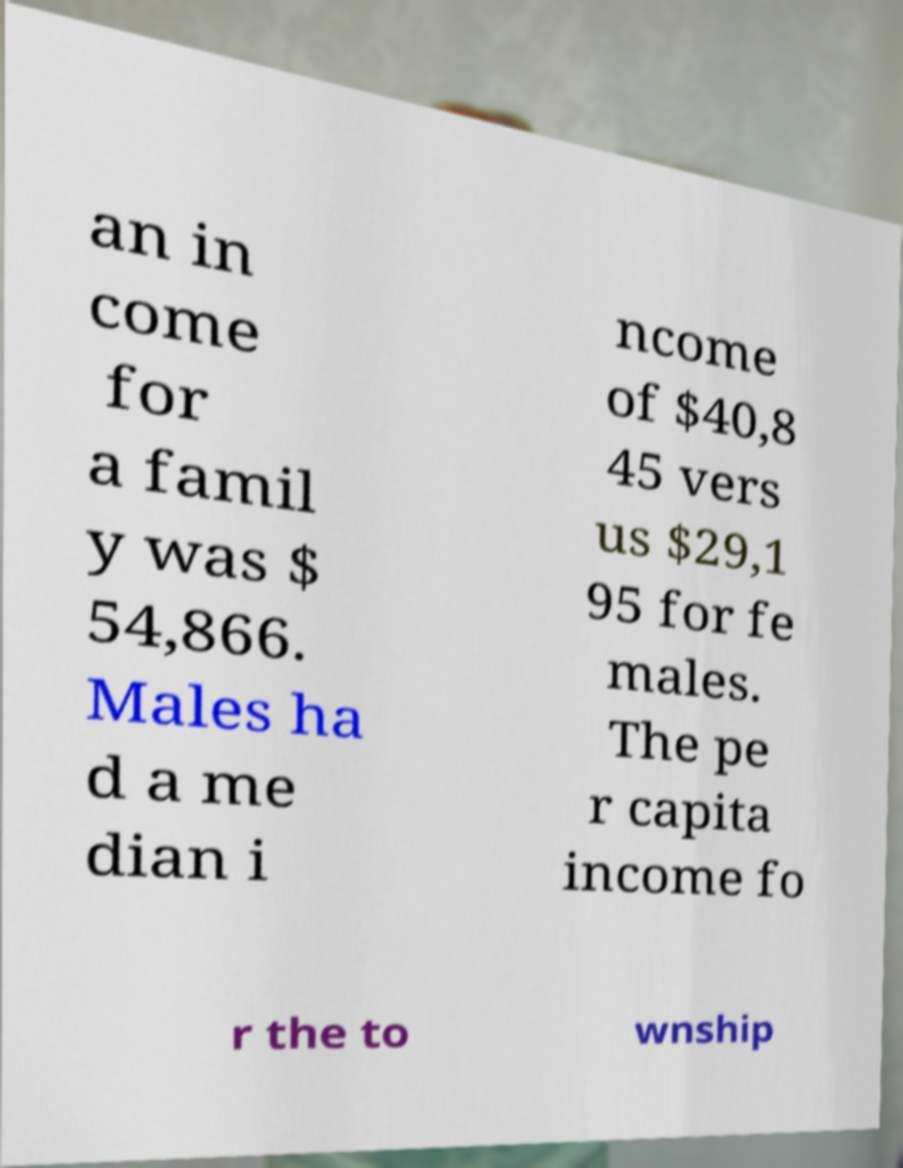Please identify and transcribe the text found in this image. an in come for a famil y was $ 54,866. Males ha d a me dian i ncome of $40,8 45 vers us $29,1 95 for fe males. The pe r capita income fo r the to wnship 